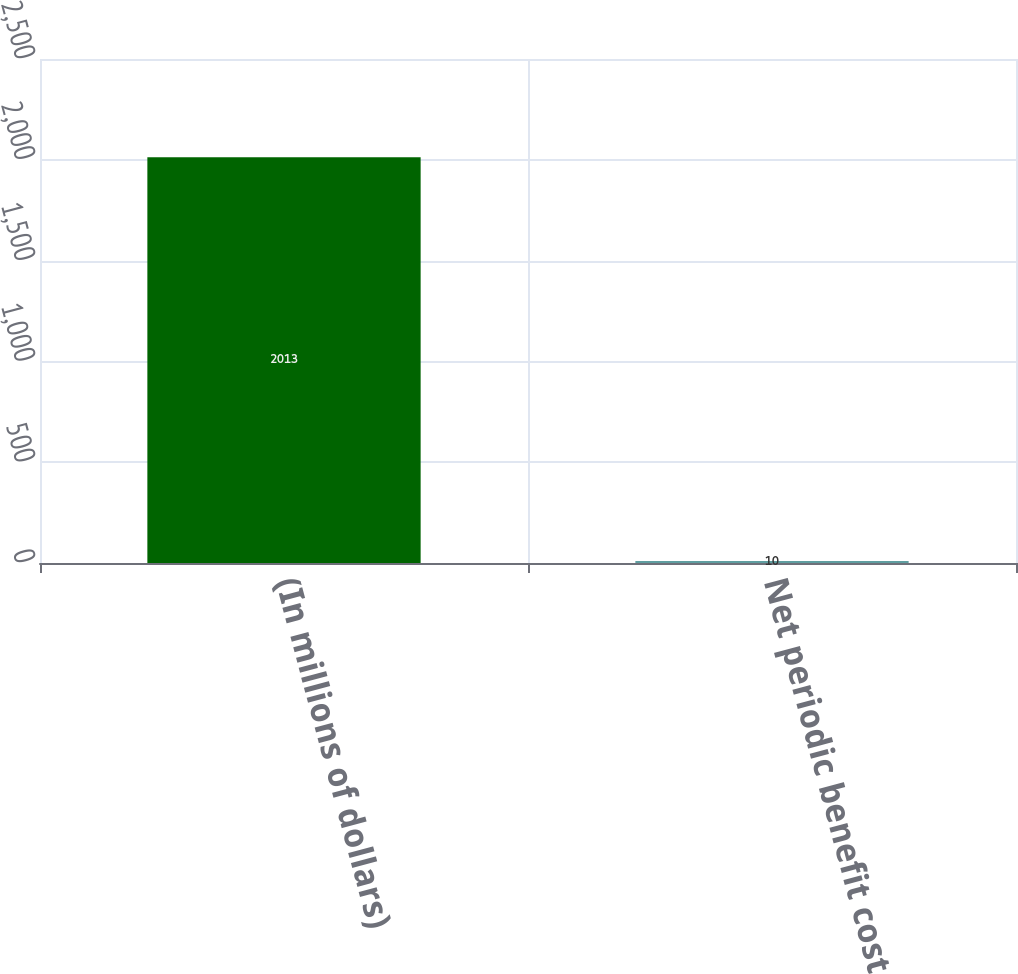Convert chart to OTSL. <chart><loc_0><loc_0><loc_500><loc_500><bar_chart><fcel>(In millions of dollars)<fcel>Net periodic benefit cost<nl><fcel>2013<fcel>10<nl></chart> 